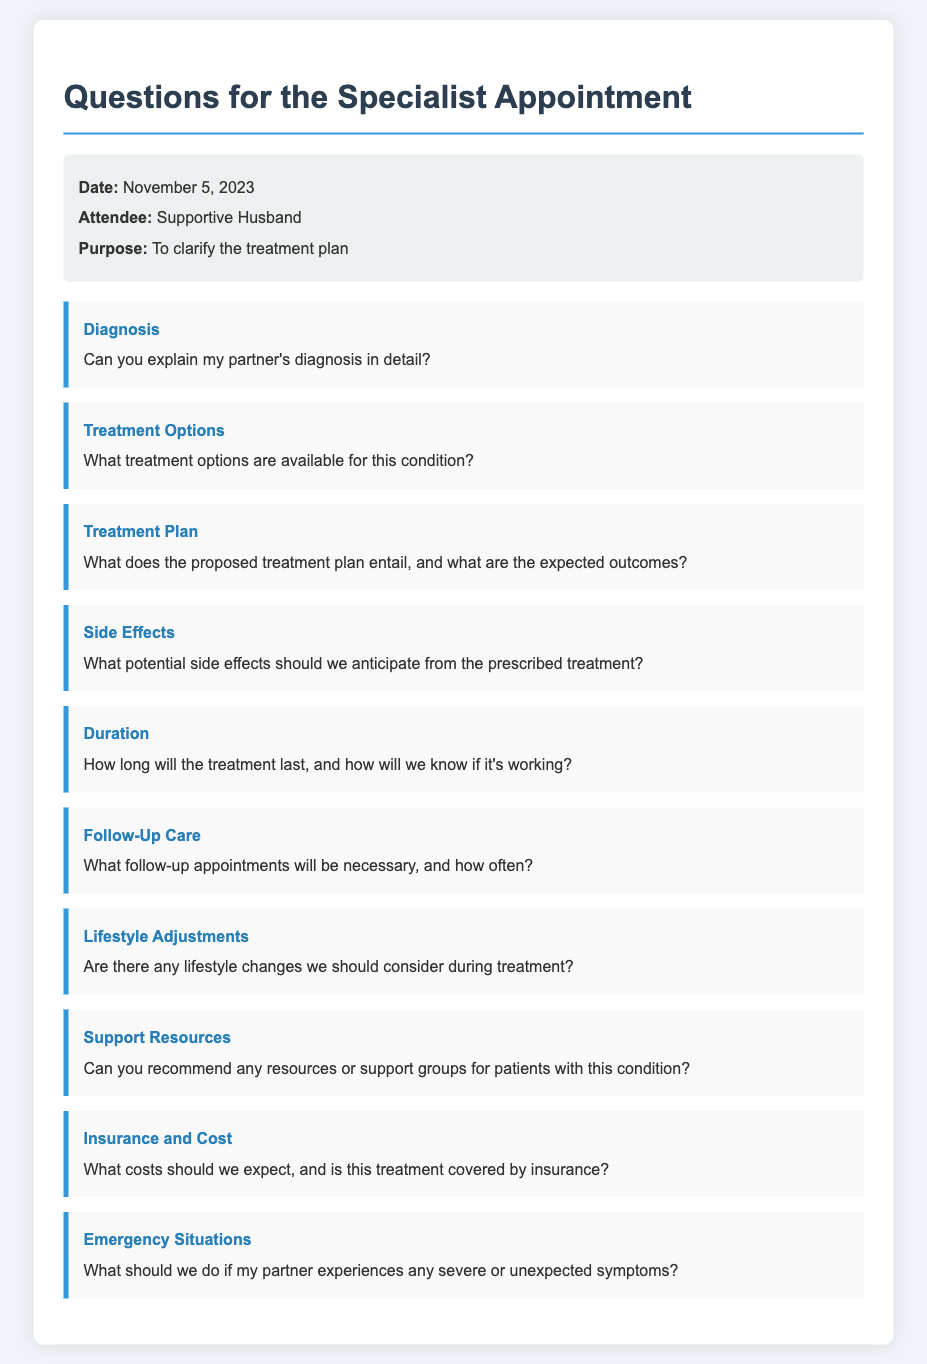What is the date of the specialist appointment? The date is mentioned in the memo to be November 5, 2023.
Answer: November 5, 2023 Who is attending the appointment? The attendee's name is specified as Supportive Husband in the document.
Answer: Supportive Husband What is the purpose of the appointment? The purpose is described as to clarify the treatment plan.
Answer: To clarify the treatment plan What should we expect regarding potential side effects? The memo specifically asks what potential side effects should be anticipated from the prescribed treatment.
Answer: Potential side effects What category does the question about follow-up appointments belong to? The memo organizes questions into categories, with follow-up appointments under the category "Follow-Up Care."
Answer: Follow-Up Care How many questions are listed in the document? The document contains a total of 10 questions under various categories.
Answer: 10 questions What type of resources does the memo inquire about? The document includes a question about recommending resources or support groups for patients.
Answer: Resources or support groups What information is requested about treatment costs? The memo asks specifically about costs we should expect and whether the treatment is covered by insurance.
Answer: Costs and insurance coverage 